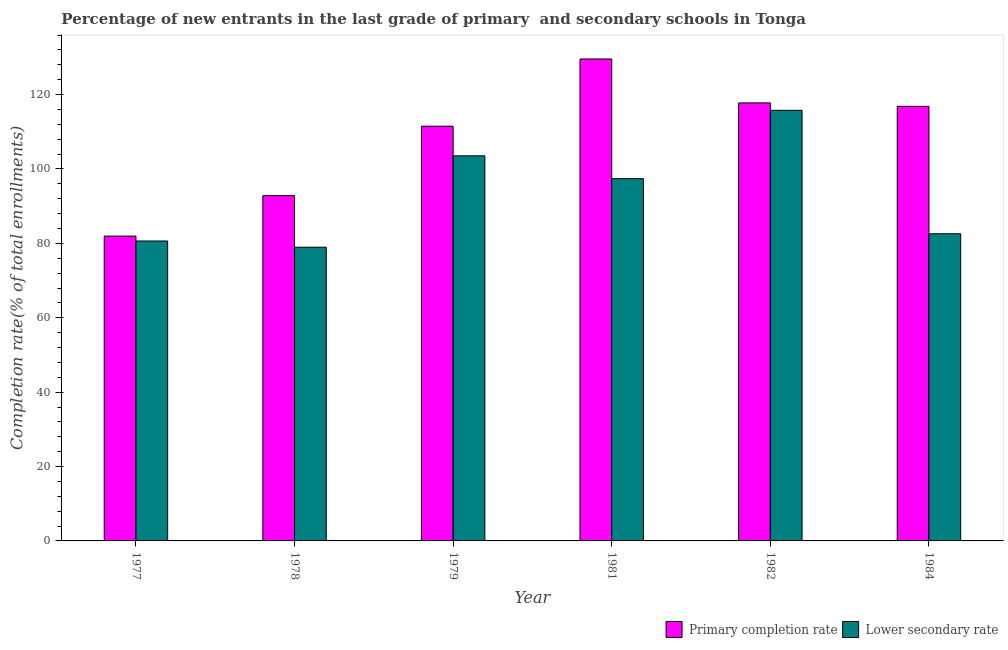How many different coloured bars are there?
Keep it short and to the point. 2. Are the number of bars on each tick of the X-axis equal?
Your answer should be very brief. Yes. What is the completion rate in primary schools in 1978?
Make the answer very short. 92.83. Across all years, what is the maximum completion rate in secondary schools?
Keep it short and to the point. 115.78. Across all years, what is the minimum completion rate in primary schools?
Ensure brevity in your answer.  81.95. In which year was the completion rate in primary schools minimum?
Your answer should be compact. 1977. What is the total completion rate in primary schools in the graph?
Your answer should be very brief. 650.48. What is the difference between the completion rate in primary schools in 1979 and that in 1981?
Your answer should be very brief. -18.08. What is the difference between the completion rate in secondary schools in 1979 and the completion rate in primary schools in 1981?
Give a very brief answer. 6.15. What is the average completion rate in secondary schools per year?
Keep it short and to the point. 93.15. In the year 1981, what is the difference between the completion rate in secondary schools and completion rate in primary schools?
Provide a short and direct response. 0. In how many years, is the completion rate in primary schools greater than 36 %?
Make the answer very short. 6. What is the ratio of the completion rate in primary schools in 1979 to that in 1982?
Make the answer very short. 0.95. Is the completion rate in secondary schools in 1979 less than that in 1981?
Make the answer very short. No. What is the difference between the highest and the second highest completion rate in primary schools?
Your answer should be very brief. 11.81. What is the difference between the highest and the lowest completion rate in primary schools?
Provide a succinct answer. 47.63. What does the 2nd bar from the left in 1982 represents?
Offer a very short reply. Lower secondary rate. What does the 1st bar from the right in 1978 represents?
Offer a terse response. Lower secondary rate. How many years are there in the graph?
Provide a succinct answer. 6. What is the difference between two consecutive major ticks on the Y-axis?
Give a very brief answer. 20. Are the values on the major ticks of Y-axis written in scientific E-notation?
Keep it short and to the point. No. Does the graph contain grids?
Offer a very short reply. No. What is the title of the graph?
Offer a very short reply. Percentage of new entrants in the last grade of primary  and secondary schools in Tonga. What is the label or title of the X-axis?
Make the answer very short. Year. What is the label or title of the Y-axis?
Provide a short and direct response. Completion rate(% of total enrollments). What is the Completion rate(% of total enrollments) of Primary completion rate in 1977?
Offer a very short reply. 81.95. What is the Completion rate(% of total enrollments) in Lower secondary rate in 1977?
Offer a very short reply. 80.64. What is the Completion rate(% of total enrollments) in Primary completion rate in 1978?
Your response must be concise. 92.83. What is the Completion rate(% of total enrollments) in Lower secondary rate in 1978?
Offer a very short reply. 78.97. What is the Completion rate(% of total enrollments) in Primary completion rate in 1979?
Keep it short and to the point. 111.5. What is the Completion rate(% of total enrollments) in Lower secondary rate in 1979?
Your answer should be very brief. 103.54. What is the Completion rate(% of total enrollments) of Primary completion rate in 1981?
Provide a short and direct response. 129.58. What is the Completion rate(% of total enrollments) of Lower secondary rate in 1981?
Your answer should be compact. 97.39. What is the Completion rate(% of total enrollments) in Primary completion rate in 1982?
Your answer should be compact. 117.77. What is the Completion rate(% of total enrollments) in Lower secondary rate in 1982?
Ensure brevity in your answer.  115.78. What is the Completion rate(% of total enrollments) in Primary completion rate in 1984?
Make the answer very short. 116.85. What is the Completion rate(% of total enrollments) in Lower secondary rate in 1984?
Offer a terse response. 82.58. Across all years, what is the maximum Completion rate(% of total enrollments) of Primary completion rate?
Provide a short and direct response. 129.58. Across all years, what is the maximum Completion rate(% of total enrollments) of Lower secondary rate?
Ensure brevity in your answer.  115.78. Across all years, what is the minimum Completion rate(% of total enrollments) in Primary completion rate?
Make the answer very short. 81.95. Across all years, what is the minimum Completion rate(% of total enrollments) of Lower secondary rate?
Keep it short and to the point. 78.97. What is the total Completion rate(% of total enrollments) in Primary completion rate in the graph?
Offer a very short reply. 650.48. What is the total Completion rate(% of total enrollments) in Lower secondary rate in the graph?
Provide a short and direct response. 558.9. What is the difference between the Completion rate(% of total enrollments) of Primary completion rate in 1977 and that in 1978?
Provide a succinct answer. -10.88. What is the difference between the Completion rate(% of total enrollments) in Lower secondary rate in 1977 and that in 1978?
Provide a short and direct response. 1.67. What is the difference between the Completion rate(% of total enrollments) of Primary completion rate in 1977 and that in 1979?
Make the answer very short. -29.55. What is the difference between the Completion rate(% of total enrollments) in Lower secondary rate in 1977 and that in 1979?
Your answer should be compact. -22.9. What is the difference between the Completion rate(% of total enrollments) of Primary completion rate in 1977 and that in 1981?
Provide a short and direct response. -47.63. What is the difference between the Completion rate(% of total enrollments) in Lower secondary rate in 1977 and that in 1981?
Keep it short and to the point. -16.75. What is the difference between the Completion rate(% of total enrollments) of Primary completion rate in 1977 and that in 1982?
Keep it short and to the point. -35.81. What is the difference between the Completion rate(% of total enrollments) in Lower secondary rate in 1977 and that in 1982?
Offer a terse response. -35.13. What is the difference between the Completion rate(% of total enrollments) in Primary completion rate in 1977 and that in 1984?
Make the answer very short. -34.89. What is the difference between the Completion rate(% of total enrollments) in Lower secondary rate in 1977 and that in 1984?
Keep it short and to the point. -1.94. What is the difference between the Completion rate(% of total enrollments) in Primary completion rate in 1978 and that in 1979?
Offer a terse response. -18.67. What is the difference between the Completion rate(% of total enrollments) of Lower secondary rate in 1978 and that in 1979?
Make the answer very short. -24.57. What is the difference between the Completion rate(% of total enrollments) of Primary completion rate in 1978 and that in 1981?
Your response must be concise. -36.75. What is the difference between the Completion rate(% of total enrollments) of Lower secondary rate in 1978 and that in 1981?
Your answer should be very brief. -18.43. What is the difference between the Completion rate(% of total enrollments) of Primary completion rate in 1978 and that in 1982?
Offer a very short reply. -24.94. What is the difference between the Completion rate(% of total enrollments) of Lower secondary rate in 1978 and that in 1982?
Your answer should be very brief. -36.81. What is the difference between the Completion rate(% of total enrollments) in Primary completion rate in 1978 and that in 1984?
Ensure brevity in your answer.  -24.01. What is the difference between the Completion rate(% of total enrollments) in Lower secondary rate in 1978 and that in 1984?
Offer a terse response. -3.62. What is the difference between the Completion rate(% of total enrollments) of Primary completion rate in 1979 and that in 1981?
Ensure brevity in your answer.  -18.08. What is the difference between the Completion rate(% of total enrollments) of Lower secondary rate in 1979 and that in 1981?
Provide a short and direct response. 6.15. What is the difference between the Completion rate(% of total enrollments) of Primary completion rate in 1979 and that in 1982?
Make the answer very short. -6.27. What is the difference between the Completion rate(% of total enrollments) of Lower secondary rate in 1979 and that in 1982?
Provide a succinct answer. -12.23. What is the difference between the Completion rate(% of total enrollments) in Primary completion rate in 1979 and that in 1984?
Ensure brevity in your answer.  -5.35. What is the difference between the Completion rate(% of total enrollments) in Lower secondary rate in 1979 and that in 1984?
Your response must be concise. 20.96. What is the difference between the Completion rate(% of total enrollments) in Primary completion rate in 1981 and that in 1982?
Offer a very short reply. 11.81. What is the difference between the Completion rate(% of total enrollments) of Lower secondary rate in 1981 and that in 1982?
Ensure brevity in your answer.  -18.38. What is the difference between the Completion rate(% of total enrollments) of Primary completion rate in 1981 and that in 1984?
Your answer should be compact. 12.73. What is the difference between the Completion rate(% of total enrollments) in Lower secondary rate in 1981 and that in 1984?
Give a very brief answer. 14.81. What is the difference between the Completion rate(% of total enrollments) in Primary completion rate in 1982 and that in 1984?
Make the answer very short. 0.92. What is the difference between the Completion rate(% of total enrollments) in Lower secondary rate in 1982 and that in 1984?
Give a very brief answer. 33.19. What is the difference between the Completion rate(% of total enrollments) in Primary completion rate in 1977 and the Completion rate(% of total enrollments) in Lower secondary rate in 1978?
Keep it short and to the point. 2.99. What is the difference between the Completion rate(% of total enrollments) in Primary completion rate in 1977 and the Completion rate(% of total enrollments) in Lower secondary rate in 1979?
Make the answer very short. -21.59. What is the difference between the Completion rate(% of total enrollments) of Primary completion rate in 1977 and the Completion rate(% of total enrollments) of Lower secondary rate in 1981?
Keep it short and to the point. -15.44. What is the difference between the Completion rate(% of total enrollments) of Primary completion rate in 1977 and the Completion rate(% of total enrollments) of Lower secondary rate in 1982?
Offer a terse response. -33.82. What is the difference between the Completion rate(% of total enrollments) in Primary completion rate in 1977 and the Completion rate(% of total enrollments) in Lower secondary rate in 1984?
Give a very brief answer. -0.63. What is the difference between the Completion rate(% of total enrollments) in Primary completion rate in 1978 and the Completion rate(% of total enrollments) in Lower secondary rate in 1979?
Your answer should be very brief. -10.71. What is the difference between the Completion rate(% of total enrollments) in Primary completion rate in 1978 and the Completion rate(% of total enrollments) in Lower secondary rate in 1981?
Your answer should be very brief. -4.56. What is the difference between the Completion rate(% of total enrollments) in Primary completion rate in 1978 and the Completion rate(% of total enrollments) in Lower secondary rate in 1982?
Ensure brevity in your answer.  -22.94. What is the difference between the Completion rate(% of total enrollments) of Primary completion rate in 1978 and the Completion rate(% of total enrollments) of Lower secondary rate in 1984?
Keep it short and to the point. 10.25. What is the difference between the Completion rate(% of total enrollments) in Primary completion rate in 1979 and the Completion rate(% of total enrollments) in Lower secondary rate in 1981?
Your answer should be very brief. 14.11. What is the difference between the Completion rate(% of total enrollments) in Primary completion rate in 1979 and the Completion rate(% of total enrollments) in Lower secondary rate in 1982?
Keep it short and to the point. -4.27. What is the difference between the Completion rate(% of total enrollments) in Primary completion rate in 1979 and the Completion rate(% of total enrollments) in Lower secondary rate in 1984?
Offer a very short reply. 28.92. What is the difference between the Completion rate(% of total enrollments) in Primary completion rate in 1981 and the Completion rate(% of total enrollments) in Lower secondary rate in 1982?
Provide a succinct answer. 13.8. What is the difference between the Completion rate(% of total enrollments) in Primary completion rate in 1981 and the Completion rate(% of total enrollments) in Lower secondary rate in 1984?
Your answer should be compact. 47. What is the difference between the Completion rate(% of total enrollments) in Primary completion rate in 1982 and the Completion rate(% of total enrollments) in Lower secondary rate in 1984?
Keep it short and to the point. 35.18. What is the average Completion rate(% of total enrollments) of Primary completion rate per year?
Your response must be concise. 108.41. What is the average Completion rate(% of total enrollments) in Lower secondary rate per year?
Your answer should be compact. 93.15. In the year 1977, what is the difference between the Completion rate(% of total enrollments) in Primary completion rate and Completion rate(% of total enrollments) in Lower secondary rate?
Your response must be concise. 1.31. In the year 1978, what is the difference between the Completion rate(% of total enrollments) of Primary completion rate and Completion rate(% of total enrollments) of Lower secondary rate?
Offer a very short reply. 13.86. In the year 1979, what is the difference between the Completion rate(% of total enrollments) in Primary completion rate and Completion rate(% of total enrollments) in Lower secondary rate?
Offer a terse response. 7.96. In the year 1981, what is the difference between the Completion rate(% of total enrollments) of Primary completion rate and Completion rate(% of total enrollments) of Lower secondary rate?
Make the answer very short. 32.19. In the year 1982, what is the difference between the Completion rate(% of total enrollments) in Primary completion rate and Completion rate(% of total enrollments) in Lower secondary rate?
Your answer should be very brief. 1.99. In the year 1984, what is the difference between the Completion rate(% of total enrollments) in Primary completion rate and Completion rate(% of total enrollments) in Lower secondary rate?
Offer a terse response. 34.26. What is the ratio of the Completion rate(% of total enrollments) of Primary completion rate in 1977 to that in 1978?
Ensure brevity in your answer.  0.88. What is the ratio of the Completion rate(% of total enrollments) of Lower secondary rate in 1977 to that in 1978?
Provide a short and direct response. 1.02. What is the ratio of the Completion rate(% of total enrollments) in Primary completion rate in 1977 to that in 1979?
Offer a very short reply. 0.73. What is the ratio of the Completion rate(% of total enrollments) of Lower secondary rate in 1977 to that in 1979?
Your answer should be very brief. 0.78. What is the ratio of the Completion rate(% of total enrollments) of Primary completion rate in 1977 to that in 1981?
Ensure brevity in your answer.  0.63. What is the ratio of the Completion rate(% of total enrollments) in Lower secondary rate in 1977 to that in 1981?
Provide a succinct answer. 0.83. What is the ratio of the Completion rate(% of total enrollments) of Primary completion rate in 1977 to that in 1982?
Offer a very short reply. 0.7. What is the ratio of the Completion rate(% of total enrollments) of Lower secondary rate in 1977 to that in 1982?
Give a very brief answer. 0.7. What is the ratio of the Completion rate(% of total enrollments) of Primary completion rate in 1977 to that in 1984?
Offer a very short reply. 0.7. What is the ratio of the Completion rate(% of total enrollments) in Lower secondary rate in 1977 to that in 1984?
Offer a very short reply. 0.98. What is the ratio of the Completion rate(% of total enrollments) in Primary completion rate in 1978 to that in 1979?
Give a very brief answer. 0.83. What is the ratio of the Completion rate(% of total enrollments) in Lower secondary rate in 1978 to that in 1979?
Your answer should be very brief. 0.76. What is the ratio of the Completion rate(% of total enrollments) in Primary completion rate in 1978 to that in 1981?
Ensure brevity in your answer.  0.72. What is the ratio of the Completion rate(% of total enrollments) of Lower secondary rate in 1978 to that in 1981?
Keep it short and to the point. 0.81. What is the ratio of the Completion rate(% of total enrollments) in Primary completion rate in 1978 to that in 1982?
Your answer should be very brief. 0.79. What is the ratio of the Completion rate(% of total enrollments) in Lower secondary rate in 1978 to that in 1982?
Provide a succinct answer. 0.68. What is the ratio of the Completion rate(% of total enrollments) of Primary completion rate in 1978 to that in 1984?
Your response must be concise. 0.79. What is the ratio of the Completion rate(% of total enrollments) of Lower secondary rate in 1978 to that in 1984?
Make the answer very short. 0.96. What is the ratio of the Completion rate(% of total enrollments) of Primary completion rate in 1979 to that in 1981?
Ensure brevity in your answer.  0.86. What is the ratio of the Completion rate(% of total enrollments) of Lower secondary rate in 1979 to that in 1981?
Make the answer very short. 1.06. What is the ratio of the Completion rate(% of total enrollments) of Primary completion rate in 1979 to that in 1982?
Give a very brief answer. 0.95. What is the ratio of the Completion rate(% of total enrollments) in Lower secondary rate in 1979 to that in 1982?
Give a very brief answer. 0.89. What is the ratio of the Completion rate(% of total enrollments) in Primary completion rate in 1979 to that in 1984?
Your answer should be very brief. 0.95. What is the ratio of the Completion rate(% of total enrollments) in Lower secondary rate in 1979 to that in 1984?
Ensure brevity in your answer.  1.25. What is the ratio of the Completion rate(% of total enrollments) of Primary completion rate in 1981 to that in 1982?
Provide a succinct answer. 1.1. What is the ratio of the Completion rate(% of total enrollments) of Lower secondary rate in 1981 to that in 1982?
Your response must be concise. 0.84. What is the ratio of the Completion rate(% of total enrollments) in Primary completion rate in 1981 to that in 1984?
Give a very brief answer. 1.11. What is the ratio of the Completion rate(% of total enrollments) in Lower secondary rate in 1981 to that in 1984?
Provide a succinct answer. 1.18. What is the ratio of the Completion rate(% of total enrollments) in Primary completion rate in 1982 to that in 1984?
Keep it short and to the point. 1.01. What is the ratio of the Completion rate(% of total enrollments) in Lower secondary rate in 1982 to that in 1984?
Offer a terse response. 1.4. What is the difference between the highest and the second highest Completion rate(% of total enrollments) in Primary completion rate?
Your answer should be compact. 11.81. What is the difference between the highest and the second highest Completion rate(% of total enrollments) of Lower secondary rate?
Give a very brief answer. 12.23. What is the difference between the highest and the lowest Completion rate(% of total enrollments) in Primary completion rate?
Ensure brevity in your answer.  47.63. What is the difference between the highest and the lowest Completion rate(% of total enrollments) in Lower secondary rate?
Offer a very short reply. 36.81. 